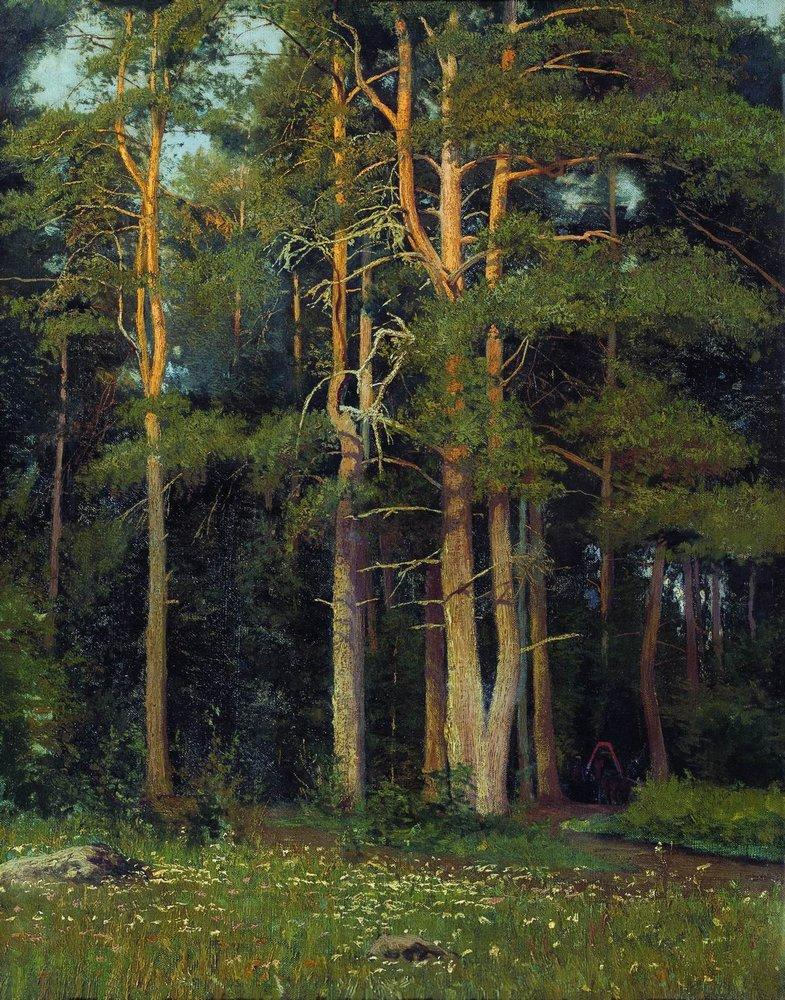This forest seems really peaceful. Do you think it ever gets loud or dangerous? While the forest depicted in this painting exudes peace and tranquility, it is not immune to the dynamic forces of nature that can bring moments of intensity. During a thunderstorm, the forest would be awash with the sounds of heavy raindrops, booming thunder, and the occasional crack of a falling branch. In the autumn, the rustle of fallen leaves underfoot might be punctuated by the calls of animals preparing for winter. Despite these moments, the forest is fundamentally a serene sanctuary, where such disturbances are simply part of the natural cycle, reinforcing the resilience and beauty of the ecosystem. What time of day do you think it is in the painting? Judging by the soft, diffused light filtering through the trees, it appears to be either early morning or late afternoon. During these times, the sun is lower in the sky, casting longer shadows and illuminating the forest with a gentle, golden light. This contributes to the serene and tranquil atmosphere of the scene. 